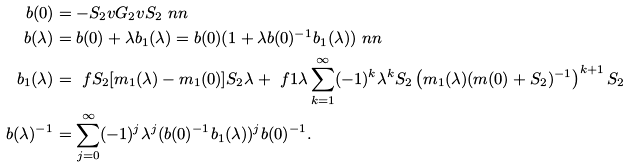Convert formula to latex. <formula><loc_0><loc_0><loc_500><loc_500>b ( 0 ) & = - S _ { 2 } v G _ { 2 } v S _ { 2 } \ n n \\ b ( \lambda ) & = b ( 0 ) + \lambda b _ { 1 } ( \lambda ) = b ( 0 ) ( 1 + \lambda b ( 0 ) ^ { - 1 } b _ { 1 } ( \lambda ) ) \ n n \\ b _ { 1 } ( \lambda ) & = \ f { S _ { 2 } [ m _ { 1 } ( \lambda ) - m _ { 1 } ( 0 ) ] S _ { 2 } } { \lambda } + \ f { 1 } { \lambda } \sum _ { k = 1 } ^ { \infty } ( - 1 ) ^ { k } \lambda ^ { k } S _ { 2 } \left ( m _ { 1 } ( \lambda ) ( m ( 0 ) + S _ { 2 } ) ^ { - 1 } \right ) ^ { k + 1 } S _ { 2 } \\ b ( \lambda ) ^ { - 1 } & = \sum _ { j = 0 } ^ { \infty } ( - 1 ) ^ { j } \lambda ^ { j } ( b ( 0 ) ^ { - 1 } b _ { 1 } ( \lambda ) ) ^ { j } b ( 0 ) ^ { - 1 } .</formula> 